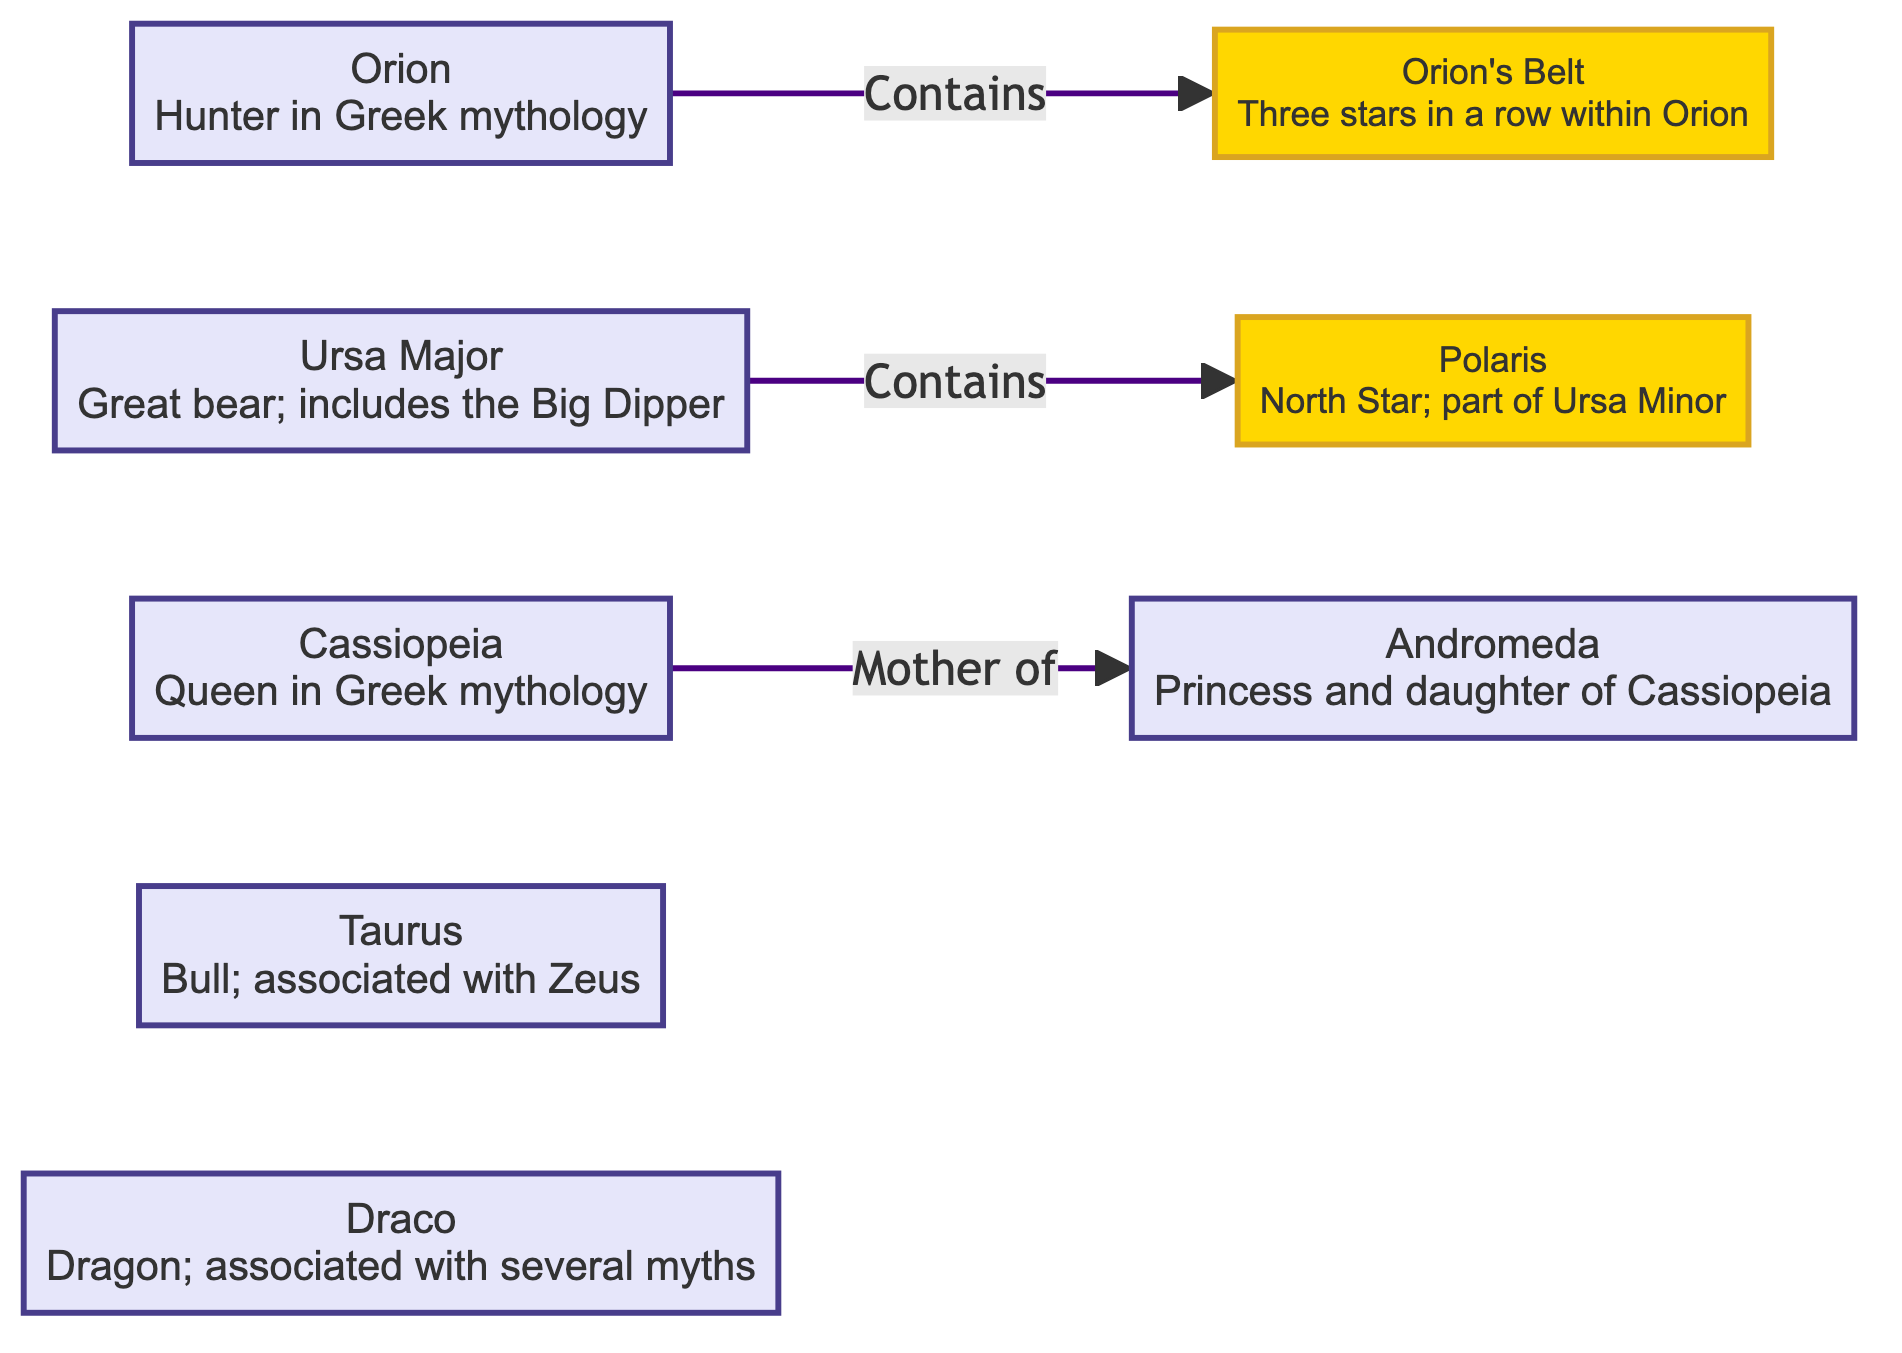What is the name of the constellation associated with the bull? The diagram shows Taurus as the constellation that represents the bull in mythology.
Answer: Taurus How many constellations are shown in the diagram? The diagram lists six constellations: Orion, Ursa Major, Cassiopeia, Taurus, Draco, and Andromeda. Counting these gives a total of six constellations.
Answer: 6 Which star is the North Star? According to the diagram, the North Star is identified as Polaris, which is part of Ursa Minor.
Answer: Polaris Who is the mother of Andromeda in the diagram? The diagram indicates that Cassiopeia is described as the mother of Andromeda, connecting the two constellations.
Answer: Cassiopeia What does the Orion constellation contain? The diagram illustrates that Orion contains Orion's Belt, which consists of three stars in a row.
Answer: Orion's Belt How many stars are mentioned in the diagram? The diagram identifies two stars: Orion's Belt and Polaris. Thus, the total number of stars mentioned is two.
Answer: 2 Which constellation is associated with a dragon? Draco is identified in the diagram as the constellation associated with a dragon, highlighting its cultural significance.
Answer: Draco What does Ursa Major include? The diagram specifies that Ursa Major includes the Big Dipper, which is a well-known asterism within this constellation.
Answer: Big Dipper Which constellation relates to Zeus? Taurus is related to Zeus according to the information provided in the diagram, illustrating its connection to Greek mythology.
Answer: Taurus 